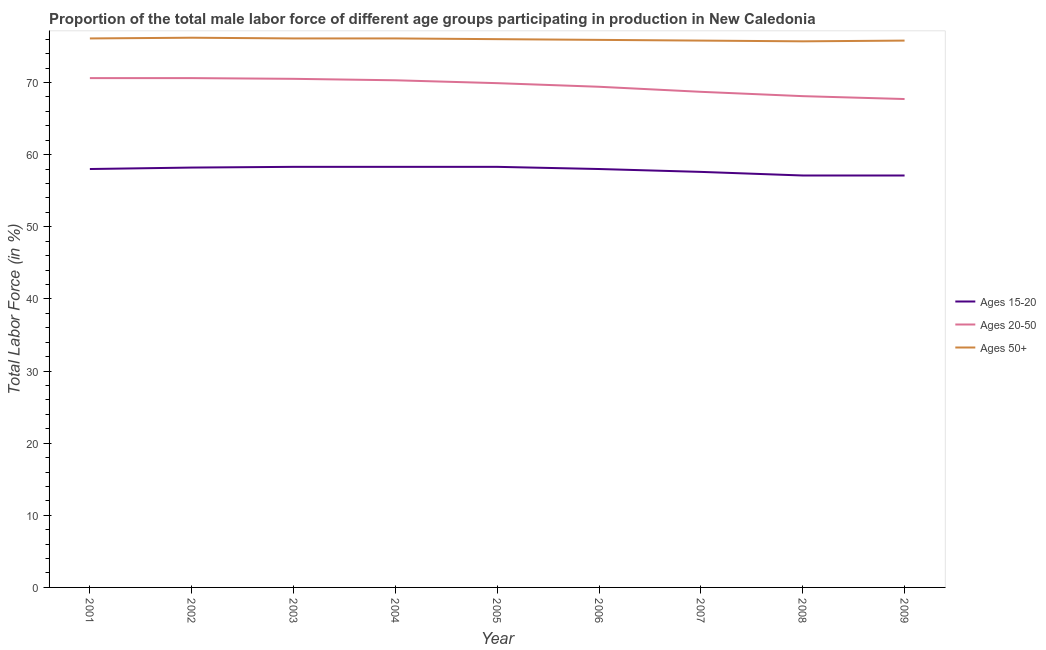What is the percentage of male labor force above age 50 in 2002?
Make the answer very short. 76.2. Across all years, what is the maximum percentage of male labor force within the age group 20-50?
Give a very brief answer. 70.6. Across all years, what is the minimum percentage of male labor force within the age group 15-20?
Provide a succinct answer. 57.1. In which year was the percentage of male labor force above age 50 minimum?
Your answer should be very brief. 2008. What is the total percentage of male labor force above age 50 in the graph?
Provide a succinct answer. 683.7. What is the difference between the percentage of male labor force within the age group 15-20 in 2005 and that in 2007?
Make the answer very short. 0.7. What is the average percentage of male labor force within the age group 15-20 per year?
Your answer should be compact. 57.88. In the year 2005, what is the difference between the percentage of male labor force above age 50 and percentage of male labor force within the age group 20-50?
Make the answer very short. 6.1. In how many years, is the percentage of male labor force within the age group 20-50 greater than 10 %?
Provide a short and direct response. 9. Is the difference between the percentage of male labor force above age 50 in 2005 and 2006 greater than the difference between the percentage of male labor force within the age group 20-50 in 2005 and 2006?
Your answer should be compact. No. In how many years, is the percentage of male labor force within the age group 15-20 greater than the average percentage of male labor force within the age group 15-20 taken over all years?
Give a very brief answer. 6. Is the sum of the percentage of male labor force above age 50 in 2002 and 2007 greater than the maximum percentage of male labor force within the age group 15-20 across all years?
Ensure brevity in your answer.  Yes. Is it the case that in every year, the sum of the percentage of male labor force within the age group 15-20 and percentage of male labor force within the age group 20-50 is greater than the percentage of male labor force above age 50?
Keep it short and to the point. Yes. What is the title of the graph?
Provide a succinct answer. Proportion of the total male labor force of different age groups participating in production in New Caledonia. Does "Errors" appear as one of the legend labels in the graph?
Give a very brief answer. No. What is the label or title of the X-axis?
Make the answer very short. Year. What is the Total Labor Force (in %) of Ages 15-20 in 2001?
Your answer should be very brief. 58. What is the Total Labor Force (in %) in Ages 20-50 in 2001?
Your answer should be very brief. 70.6. What is the Total Labor Force (in %) of Ages 50+ in 2001?
Ensure brevity in your answer.  76.1. What is the Total Labor Force (in %) of Ages 15-20 in 2002?
Make the answer very short. 58.2. What is the Total Labor Force (in %) in Ages 20-50 in 2002?
Make the answer very short. 70.6. What is the Total Labor Force (in %) of Ages 50+ in 2002?
Keep it short and to the point. 76.2. What is the Total Labor Force (in %) in Ages 15-20 in 2003?
Your answer should be compact. 58.3. What is the Total Labor Force (in %) in Ages 20-50 in 2003?
Your response must be concise. 70.5. What is the Total Labor Force (in %) in Ages 50+ in 2003?
Your answer should be very brief. 76.1. What is the Total Labor Force (in %) of Ages 15-20 in 2004?
Offer a very short reply. 58.3. What is the Total Labor Force (in %) in Ages 20-50 in 2004?
Provide a short and direct response. 70.3. What is the Total Labor Force (in %) in Ages 50+ in 2004?
Your answer should be compact. 76.1. What is the Total Labor Force (in %) of Ages 15-20 in 2005?
Give a very brief answer. 58.3. What is the Total Labor Force (in %) of Ages 20-50 in 2005?
Your response must be concise. 69.9. What is the Total Labor Force (in %) of Ages 50+ in 2005?
Your answer should be compact. 76. What is the Total Labor Force (in %) in Ages 15-20 in 2006?
Keep it short and to the point. 58. What is the Total Labor Force (in %) in Ages 20-50 in 2006?
Ensure brevity in your answer.  69.4. What is the Total Labor Force (in %) in Ages 50+ in 2006?
Ensure brevity in your answer.  75.9. What is the Total Labor Force (in %) in Ages 15-20 in 2007?
Give a very brief answer. 57.6. What is the Total Labor Force (in %) of Ages 20-50 in 2007?
Ensure brevity in your answer.  68.7. What is the Total Labor Force (in %) of Ages 50+ in 2007?
Your answer should be very brief. 75.8. What is the Total Labor Force (in %) of Ages 15-20 in 2008?
Offer a very short reply. 57.1. What is the Total Labor Force (in %) in Ages 20-50 in 2008?
Your answer should be compact. 68.1. What is the Total Labor Force (in %) of Ages 50+ in 2008?
Make the answer very short. 75.7. What is the Total Labor Force (in %) of Ages 15-20 in 2009?
Ensure brevity in your answer.  57.1. What is the Total Labor Force (in %) in Ages 20-50 in 2009?
Offer a terse response. 67.7. What is the Total Labor Force (in %) of Ages 50+ in 2009?
Your response must be concise. 75.8. Across all years, what is the maximum Total Labor Force (in %) in Ages 15-20?
Provide a succinct answer. 58.3. Across all years, what is the maximum Total Labor Force (in %) in Ages 20-50?
Make the answer very short. 70.6. Across all years, what is the maximum Total Labor Force (in %) of Ages 50+?
Make the answer very short. 76.2. Across all years, what is the minimum Total Labor Force (in %) of Ages 15-20?
Ensure brevity in your answer.  57.1. Across all years, what is the minimum Total Labor Force (in %) in Ages 20-50?
Give a very brief answer. 67.7. Across all years, what is the minimum Total Labor Force (in %) in Ages 50+?
Make the answer very short. 75.7. What is the total Total Labor Force (in %) in Ages 15-20 in the graph?
Ensure brevity in your answer.  520.9. What is the total Total Labor Force (in %) of Ages 20-50 in the graph?
Offer a very short reply. 625.8. What is the total Total Labor Force (in %) of Ages 50+ in the graph?
Your answer should be compact. 683.7. What is the difference between the Total Labor Force (in %) in Ages 15-20 in 2001 and that in 2002?
Your response must be concise. -0.2. What is the difference between the Total Labor Force (in %) in Ages 20-50 in 2001 and that in 2002?
Provide a short and direct response. 0. What is the difference between the Total Labor Force (in %) of Ages 50+ in 2001 and that in 2002?
Offer a terse response. -0.1. What is the difference between the Total Labor Force (in %) of Ages 15-20 in 2001 and that in 2003?
Your response must be concise. -0.3. What is the difference between the Total Labor Force (in %) of Ages 15-20 in 2001 and that in 2004?
Offer a terse response. -0.3. What is the difference between the Total Labor Force (in %) of Ages 50+ in 2001 and that in 2004?
Offer a terse response. 0. What is the difference between the Total Labor Force (in %) of Ages 50+ in 2001 and that in 2005?
Make the answer very short. 0.1. What is the difference between the Total Labor Force (in %) in Ages 15-20 in 2001 and that in 2006?
Provide a short and direct response. 0. What is the difference between the Total Labor Force (in %) of Ages 20-50 in 2001 and that in 2006?
Ensure brevity in your answer.  1.2. What is the difference between the Total Labor Force (in %) in Ages 50+ in 2001 and that in 2006?
Your answer should be very brief. 0.2. What is the difference between the Total Labor Force (in %) of Ages 15-20 in 2001 and that in 2007?
Your response must be concise. 0.4. What is the difference between the Total Labor Force (in %) in Ages 50+ in 2001 and that in 2007?
Offer a terse response. 0.3. What is the difference between the Total Labor Force (in %) in Ages 15-20 in 2001 and that in 2008?
Your response must be concise. 0.9. What is the difference between the Total Labor Force (in %) of Ages 20-50 in 2001 and that in 2008?
Make the answer very short. 2.5. What is the difference between the Total Labor Force (in %) of Ages 20-50 in 2001 and that in 2009?
Make the answer very short. 2.9. What is the difference between the Total Labor Force (in %) in Ages 50+ in 2001 and that in 2009?
Offer a very short reply. 0.3. What is the difference between the Total Labor Force (in %) in Ages 15-20 in 2002 and that in 2003?
Ensure brevity in your answer.  -0.1. What is the difference between the Total Labor Force (in %) in Ages 50+ in 2002 and that in 2003?
Make the answer very short. 0.1. What is the difference between the Total Labor Force (in %) in Ages 20-50 in 2002 and that in 2004?
Offer a terse response. 0.3. What is the difference between the Total Labor Force (in %) in Ages 20-50 in 2002 and that in 2006?
Your answer should be very brief. 1.2. What is the difference between the Total Labor Force (in %) of Ages 50+ in 2002 and that in 2006?
Provide a short and direct response. 0.3. What is the difference between the Total Labor Force (in %) in Ages 20-50 in 2002 and that in 2007?
Give a very brief answer. 1.9. What is the difference between the Total Labor Force (in %) of Ages 20-50 in 2002 and that in 2009?
Provide a succinct answer. 2.9. What is the difference between the Total Labor Force (in %) of Ages 15-20 in 2003 and that in 2004?
Provide a succinct answer. 0. What is the difference between the Total Labor Force (in %) of Ages 50+ in 2003 and that in 2005?
Your answer should be compact. 0.1. What is the difference between the Total Labor Force (in %) in Ages 15-20 in 2003 and that in 2006?
Offer a very short reply. 0.3. What is the difference between the Total Labor Force (in %) in Ages 20-50 in 2003 and that in 2006?
Your answer should be very brief. 1.1. What is the difference between the Total Labor Force (in %) of Ages 15-20 in 2003 and that in 2007?
Offer a very short reply. 0.7. What is the difference between the Total Labor Force (in %) of Ages 20-50 in 2003 and that in 2008?
Your answer should be compact. 2.4. What is the difference between the Total Labor Force (in %) in Ages 50+ in 2003 and that in 2008?
Make the answer very short. 0.4. What is the difference between the Total Labor Force (in %) of Ages 15-20 in 2003 and that in 2009?
Offer a very short reply. 1.2. What is the difference between the Total Labor Force (in %) in Ages 20-50 in 2003 and that in 2009?
Ensure brevity in your answer.  2.8. What is the difference between the Total Labor Force (in %) of Ages 15-20 in 2004 and that in 2005?
Provide a short and direct response. 0. What is the difference between the Total Labor Force (in %) of Ages 20-50 in 2004 and that in 2005?
Offer a terse response. 0.4. What is the difference between the Total Labor Force (in %) in Ages 15-20 in 2004 and that in 2006?
Provide a short and direct response. 0.3. What is the difference between the Total Labor Force (in %) of Ages 50+ in 2004 and that in 2006?
Offer a very short reply. 0.2. What is the difference between the Total Labor Force (in %) of Ages 15-20 in 2004 and that in 2007?
Ensure brevity in your answer.  0.7. What is the difference between the Total Labor Force (in %) in Ages 15-20 in 2004 and that in 2008?
Offer a terse response. 1.2. What is the difference between the Total Labor Force (in %) of Ages 15-20 in 2004 and that in 2009?
Offer a terse response. 1.2. What is the difference between the Total Labor Force (in %) of Ages 50+ in 2004 and that in 2009?
Provide a succinct answer. 0.3. What is the difference between the Total Labor Force (in %) in Ages 15-20 in 2005 and that in 2006?
Keep it short and to the point. 0.3. What is the difference between the Total Labor Force (in %) of Ages 50+ in 2005 and that in 2006?
Keep it short and to the point. 0.1. What is the difference between the Total Labor Force (in %) of Ages 15-20 in 2005 and that in 2008?
Offer a very short reply. 1.2. What is the difference between the Total Labor Force (in %) in Ages 20-50 in 2005 and that in 2008?
Offer a terse response. 1.8. What is the difference between the Total Labor Force (in %) of Ages 50+ in 2005 and that in 2008?
Ensure brevity in your answer.  0.3. What is the difference between the Total Labor Force (in %) of Ages 50+ in 2005 and that in 2009?
Offer a terse response. 0.2. What is the difference between the Total Labor Force (in %) of Ages 15-20 in 2006 and that in 2007?
Give a very brief answer. 0.4. What is the difference between the Total Labor Force (in %) in Ages 20-50 in 2006 and that in 2008?
Your answer should be compact. 1.3. What is the difference between the Total Labor Force (in %) in Ages 50+ in 2006 and that in 2008?
Provide a succinct answer. 0.2. What is the difference between the Total Labor Force (in %) of Ages 15-20 in 2006 and that in 2009?
Ensure brevity in your answer.  0.9. What is the difference between the Total Labor Force (in %) in Ages 20-50 in 2006 and that in 2009?
Offer a terse response. 1.7. What is the difference between the Total Labor Force (in %) in Ages 15-20 in 2007 and that in 2008?
Offer a very short reply. 0.5. What is the difference between the Total Labor Force (in %) in Ages 20-50 in 2007 and that in 2008?
Make the answer very short. 0.6. What is the difference between the Total Labor Force (in %) of Ages 50+ in 2007 and that in 2008?
Keep it short and to the point. 0.1. What is the difference between the Total Labor Force (in %) in Ages 50+ in 2007 and that in 2009?
Ensure brevity in your answer.  0. What is the difference between the Total Labor Force (in %) in Ages 50+ in 2008 and that in 2009?
Provide a succinct answer. -0.1. What is the difference between the Total Labor Force (in %) in Ages 15-20 in 2001 and the Total Labor Force (in %) in Ages 20-50 in 2002?
Offer a very short reply. -12.6. What is the difference between the Total Labor Force (in %) in Ages 15-20 in 2001 and the Total Labor Force (in %) in Ages 50+ in 2002?
Ensure brevity in your answer.  -18.2. What is the difference between the Total Labor Force (in %) in Ages 15-20 in 2001 and the Total Labor Force (in %) in Ages 50+ in 2003?
Your answer should be very brief. -18.1. What is the difference between the Total Labor Force (in %) of Ages 20-50 in 2001 and the Total Labor Force (in %) of Ages 50+ in 2003?
Give a very brief answer. -5.5. What is the difference between the Total Labor Force (in %) in Ages 15-20 in 2001 and the Total Labor Force (in %) in Ages 50+ in 2004?
Ensure brevity in your answer.  -18.1. What is the difference between the Total Labor Force (in %) of Ages 15-20 in 2001 and the Total Labor Force (in %) of Ages 20-50 in 2005?
Keep it short and to the point. -11.9. What is the difference between the Total Labor Force (in %) in Ages 20-50 in 2001 and the Total Labor Force (in %) in Ages 50+ in 2005?
Give a very brief answer. -5.4. What is the difference between the Total Labor Force (in %) in Ages 15-20 in 2001 and the Total Labor Force (in %) in Ages 20-50 in 2006?
Your answer should be very brief. -11.4. What is the difference between the Total Labor Force (in %) in Ages 15-20 in 2001 and the Total Labor Force (in %) in Ages 50+ in 2006?
Make the answer very short. -17.9. What is the difference between the Total Labor Force (in %) of Ages 20-50 in 2001 and the Total Labor Force (in %) of Ages 50+ in 2006?
Offer a very short reply. -5.3. What is the difference between the Total Labor Force (in %) in Ages 15-20 in 2001 and the Total Labor Force (in %) in Ages 50+ in 2007?
Make the answer very short. -17.8. What is the difference between the Total Labor Force (in %) in Ages 15-20 in 2001 and the Total Labor Force (in %) in Ages 50+ in 2008?
Your answer should be compact. -17.7. What is the difference between the Total Labor Force (in %) of Ages 20-50 in 2001 and the Total Labor Force (in %) of Ages 50+ in 2008?
Make the answer very short. -5.1. What is the difference between the Total Labor Force (in %) in Ages 15-20 in 2001 and the Total Labor Force (in %) in Ages 50+ in 2009?
Your answer should be very brief. -17.8. What is the difference between the Total Labor Force (in %) of Ages 15-20 in 2002 and the Total Labor Force (in %) of Ages 20-50 in 2003?
Your answer should be very brief. -12.3. What is the difference between the Total Labor Force (in %) in Ages 15-20 in 2002 and the Total Labor Force (in %) in Ages 50+ in 2003?
Provide a succinct answer. -17.9. What is the difference between the Total Labor Force (in %) of Ages 20-50 in 2002 and the Total Labor Force (in %) of Ages 50+ in 2003?
Provide a short and direct response. -5.5. What is the difference between the Total Labor Force (in %) of Ages 15-20 in 2002 and the Total Labor Force (in %) of Ages 20-50 in 2004?
Ensure brevity in your answer.  -12.1. What is the difference between the Total Labor Force (in %) in Ages 15-20 in 2002 and the Total Labor Force (in %) in Ages 50+ in 2004?
Offer a terse response. -17.9. What is the difference between the Total Labor Force (in %) of Ages 15-20 in 2002 and the Total Labor Force (in %) of Ages 50+ in 2005?
Provide a succinct answer. -17.8. What is the difference between the Total Labor Force (in %) in Ages 15-20 in 2002 and the Total Labor Force (in %) in Ages 50+ in 2006?
Offer a terse response. -17.7. What is the difference between the Total Labor Force (in %) of Ages 20-50 in 2002 and the Total Labor Force (in %) of Ages 50+ in 2006?
Ensure brevity in your answer.  -5.3. What is the difference between the Total Labor Force (in %) of Ages 15-20 in 2002 and the Total Labor Force (in %) of Ages 50+ in 2007?
Keep it short and to the point. -17.6. What is the difference between the Total Labor Force (in %) in Ages 20-50 in 2002 and the Total Labor Force (in %) in Ages 50+ in 2007?
Provide a short and direct response. -5.2. What is the difference between the Total Labor Force (in %) in Ages 15-20 in 2002 and the Total Labor Force (in %) in Ages 50+ in 2008?
Provide a succinct answer. -17.5. What is the difference between the Total Labor Force (in %) of Ages 20-50 in 2002 and the Total Labor Force (in %) of Ages 50+ in 2008?
Your response must be concise. -5.1. What is the difference between the Total Labor Force (in %) of Ages 15-20 in 2002 and the Total Labor Force (in %) of Ages 50+ in 2009?
Ensure brevity in your answer.  -17.6. What is the difference between the Total Labor Force (in %) in Ages 20-50 in 2002 and the Total Labor Force (in %) in Ages 50+ in 2009?
Keep it short and to the point. -5.2. What is the difference between the Total Labor Force (in %) of Ages 15-20 in 2003 and the Total Labor Force (in %) of Ages 50+ in 2004?
Provide a short and direct response. -17.8. What is the difference between the Total Labor Force (in %) in Ages 15-20 in 2003 and the Total Labor Force (in %) in Ages 50+ in 2005?
Give a very brief answer. -17.7. What is the difference between the Total Labor Force (in %) of Ages 20-50 in 2003 and the Total Labor Force (in %) of Ages 50+ in 2005?
Your answer should be very brief. -5.5. What is the difference between the Total Labor Force (in %) in Ages 15-20 in 2003 and the Total Labor Force (in %) in Ages 50+ in 2006?
Your answer should be very brief. -17.6. What is the difference between the Total Labor Force (in %) of Ages 15-20 in 2003 and the Total Labor Force (in %) of Ages 50+ in 2007?
Provide a succinct answer. -17.5. What is the difference between the Total Labor Force (in %) in Ages 15-20 in 2003 and the Total Labor Force (in %) in Ages 20-50 in 2008?
Offer a terse response. -9.8. What is the difference between the Total Labor Force (in %) in Ages 15-20 in 2003 and the Total Labor Force (in %) in Ages 50+ in 2008?
Keep it short and to the point. -17.4. What is the difference between the Total Labor Force (in %) of Ages 20-50 in 2003 and the Total Labor Force (in %) of Ages 50+ in 2008?
Your answer should be compact. -5.2. What is the difference between the Total Labor Force (in %) of Ages 15-20 in 2003 and the Total Labor Force (in %) of Ages 20-50 in 2009?
Keep it short and to the point. -9.4. What is the difference between the Total Labor Force (in %) of Ages 15-20 in 2003 and the Total Labor Force (in %) of Ages 50+ in 2009?
Your answer should be very brief. -17.5. What is the difference between the Total Labor Force (in %) in Ages 20-50 in 2003 and the Total Labor Force (in %) in Ages 50+ in 2009?
Your answer should be compact. -5.3. What is the difference between the Total Labor Force (in %) in Ages 15-20 in 2004 and the Total Labor Force (in %) in Ages 20-50 in 2005?
Ensure brevity in your answer.  -11.6. What is the difference between the Total Labor Force (in %) in Ages 15-20 in 2004 and the Total Labor Force (in %) in Ages 50+ in 2005?
Your response must be concise. -17.7. What is the difference between the Total Labor Force (in %) in Ages 15-20 in 2004 and the Total Labor Force (in %) in Ages 20-50 in 2006?
Give a very brief answer. -11.1. What is the difference between the Total Labor Force (in %) of Ages 15-20 in 2004 and the Total Labor Force (in %) of Ages 50+ in 2006?
Give a very brief answer. -17.6. What is the difference between the Total Labor Force (in %) in Ages 15-20 in 2004 and the Total Labor Force (in %) in Ages 50+ in 2007?
Give a very brief answer. -17.5. What is the difference between the Total Labor Force (in %) of Ages 20-50 in 2004 and the Total Labor Force (in %) of Ages 50+ in 2007?
Give a very brief answer. -5.5. What is the difference between the Total Labor Force (in %) of Ages 15-20 in 2004 and the Total Labor Force (in %) of Ages 50+ in 2008?
Offer a terse response. -17.4. What is the difference between the Total Labor Force (in %) in Ages 15-20 in 2004 and the Total Labor Force (in %) in Ages 20-50 in 2009?
Keep it short and to the point. -9.4. What is the difference between the Total Labor Force (in %) of Ages 15-20 in 2004 and the Total Labor Force (in %) of Ages 50+ in 2009?
Keep it short and to the point. -17.5. What is the difference between the Total Labor Force (in %) in Ages 15-20 in 2005 and the Total Labor Force (in %) in Ages 20-50 in 2006?
Offer a terse response. -11.1. What is the difference between the Total Labor Force (in %) in Ages 15-20 in 2005 and the Total Labor Force (in %) in Ages 50+ in 2006?
Provide a succinct answer. -17.6. What is the difference between the Total Labor Force (in %) of Ages 20-50 in 2005 and the Total Labor Force (in %) of Ages 50+ in 2006?
Give a very brief answer. -6. What is the difference between the Total Labor Force (in %) in Ages 15-20 in 2005 and the Total Labor Force (in %) in Ages 50+ in 2007?
Provide a short and direct response. -17.5. What is the difference between the Total Labor Force (in %) of Ages 15-20 in 2005 and the Total Labor Force (in %) of Ages 20-50 in 2008?
Offer a terse response. -9.8. What is the difference between the Total Labor Force (in %) in Ages 15-20 in 2005 and the Total Labor Force (in %) in Ages 50+ in 2008?
Your response must be concise. -17.4. What is the difference between the Total Labor Force (in %) of Ages 15-20 in 2005 and the Total Labor Force (in %) of Ages 20-50 in 2009?
Your answer should be very brief. -9.4. What is the difference between the Total Labor Force (in %) of Ages 15-20 in 2005 and the Total Labor Force (in %) of Ages 50+ in 2009?
Give a very brief answer. -17.5. What is the difference between the Total Labor Force (in %) in Ages 15-20 in 2006 and the Total Labor Force (in %) in Ages 20-50 in 2007?
Your response must be concise. -10.7. What is the difference between the Total Labor Force (in %) in Ages 15-20 in 2006 and the Total Labor Force (in %) in Ages 50+ in 2007?
Provide a short and direct response. -17.8. What is the difference between the Total Labor Force (in %) of Ages 20-50 in 2006 and the Total Labor Force (in %) of Ages 50+ in 2007?
Your answer should be very brief. -6.4. What is the difference between the Total Labor Force (in %) of Ages 15-20 in 2006 and the Total Labor Force (in %) of Ages 50+ in 2008?
Make the answer very short. -17.7. What is the difference between the Total Labor Force (in %) in Ages 15-20 in 2006 and the Total Labor Force (in %) in Ages 20-50 in 2009?
Provide a succinct answer. -9.7. What is the difference between the Total Labor Force (in %) of Ages 15-20 in 2006 and the Total Labor Force (in %) of Ages 50+ in 2009?
Give a very brief answer. -17.8. What is the difference between the Total Labor Force (in %) of Ages 20-50 in 2006 and the Total Labor Force (in %) of Ages 50+ in 2009?
Make the answer very short. -6.4. What is the difference between the Total Labor Force (in %) in Ages 15-20 in 2007 and the Total Labor Force (in %) in Ages 20-50 in 2008?
Keep it short and to the point. -10.5. What is the difference between the Total Labor Force (in %) of Ages 15-20 in 2007 and the Total Labor Force (in %) of Ages 50+ in 2008?
Your answer should be very brief. -18.1. What is the difference between the Total Labor Force (in %) in Ages 20-50 in 2007 and the Total Labor Force (in %) in Ages 50+ in 2008?
Your answer should be very brief. -7. What is the difference between the Total Labor Force (in %) of Ages 15-20 in 2007 and the Total Labor Force (in %) of Ages 20-50 in 2009?
Your response must be concise. -10.1. What is the difference between the Total Labor Force (in %) in Ages 15-20 in 2007 and the Total Labor Force (in %) in Ages 50+ in 2009?
Make the answer very short. -18.2. What is the difference between the Total Labor Force (in %) of Ages 15-20 in 2008 and the Total Labor Force (in %) of Ages 20-50 in 2009?
Give a very brief answer. -10.6. What is the difference between the Total Labor Force (in %) of Ages 15-20 in 2008 and the Total Labor Force (in %) of Ages 50+ in 2009?
Make the answer very short. -18.7. What is the average Total Labor Force (in %) in Ages 15-20 per year?
Your response must be concise. 57.88. What is the average Total Labor Force (in %) of Ages 20-50 per year?
Make the answer very short. 69.53. What is the average Total Labor Force (in %) in Ages 50+ per year?
Offer a terse response. 75.97. In the year 2001, what is the difference between the Total Labor Force (in %) of Ages 15-20 and Total Labor Force (in %) of Ages 20-50?
Your answer should be compact. -12.6. In the year 2001, what is the difference between the Total Labor Force (in %) of Ages 15-20 and Total Labor Force (in %) of Ages 50+?
Your response must be concise. -18.1. In the year 2002, what is the difference between the Total Labor Force (in %) in Ages 15-20 and Total Labor Force (in %) in Ages 50+?
Provide a short and direct response. -18. In the year 2002, what is the difference between the Total Labor Force (in %) of Ages 20-50 and Total Labor Force (in %) of Ages 50+?
Your answer should be very brief. -5.6. In the year 2003, what is the difference between the Total Labor Force (in %) in Ages 15-20 and Total Labor Force (in %) in Ages 20-50?
Your answer should be very brief. -12.2. In the year 2003, what is the difference between the Total Labor Force (in %) of Ages 15-20 and Total Labor Force (in %) of Ages 50+?
Give a very brief answer. -17.8. In the year 2003, what is the difference between the Total Labor Force (in %) in Ages 20-50 and Total Labor Force (in %) in Ages 50+?
Keep it short and to the point. -5.6. In the year 2004, what is the difference between the Total Labor Force (in %) in Ages 15-20 and Total Labor Force (in %) in Ages 50+?
Your answer should be very brief. -17.8. In the year 2005, what is the difference between the Total Labor Force (in %) of Ages 15-20 and Total Labor Force (in %) of Ages 50+?
Your answer should be compact. -17.7. In the year 2005, what is the difference between the Total Labor Force (in %) in Ages 20-50 and Total Labor Force (in %) in Ages 50+?
Provide a short and direct response. -6.1. In the year 2006, what is the difference between the Total Labor Force (in %) in Ages 15-20 and Total Labor Force (in %) in Ages 20-50?
Offer a very short reply. -11.4. In the year 2006, what is the difference between the Total Labor Force (in %) of Ages 15-20 and Total Labor Force (in %) of Ages 50+?
Make the answer very short. -17.9. In the year 2007, what is the difference between the Total Labor Force (in %) in Ages 15-20 and Total Labor Force (in %) in Ages 20-50?
Your response must be concise. -11.1. In the year 2007, what is the difference between the Total Labor Force (in %) of Ages 15-20 and Total Labor Force (in %) of Ages 50+?
Make the answer very short. -18.2. In the year 2007, what is the difference between the Total Labor Force (in %) of Ages 20-50 and Total Labor Force (in %) of Ages 50+?
Give a very brief answer. -7.1. In the year 2008, what is the difference between the Total Labor Force (in %) in Ages 15-20 and Total Labor Force (in %) in Ages 20-50?
Keep it short and to the point. -11. In the year 2008, what is the difference between the Total Labor Force (in %) in Ages 15-20 and Total Labor Force (in %) in Ages 50+?
Your response must be concise. -18.6. In the year 2008, what is the difference between the Total Labor Force (in %) of Ages 20-50 and Total Labor Force (in %) of Ages 50+?
Your answer should be very brief. -7.6. In the year 2009, what is the difference between the Total Labor Force (in %) of Ages 15-20 and Total Labor Force (in %) of Ages 20-50?
Offer a very short reply. -10.6. In the year 2009, what is the difference between the Total Labor Force (in %) in Ages 15-20 and Total Labor Force (in %) in Ages 50+?
Make the answer very short. -18.7. What is the ratio of the Total Labor Force (in %) of Ages 15-20 in 2001 to that in 2002?
Provide a short and direct response. 1. What is the ratio of the Total Labor Force (in %) of Ages 20-50 in 2001 to that in 2003?
Provide a succinct answer. 1. What is the ratio of the Total Labor Force (in %) of Ages 15-20 in 2001 to that in 2004?
Provide a short and direct response. 0.99. What is the ratio of the Total Labor Force (in %) in Ages 20-50 in 2001 to that in 2004?
Ensure brevity in your answer.  1. What is the ratio of the Total Labor Force (in %) in Ages 50+ in 2001 to that in 2004?
Your answer should be compact. 1. What is the ratio of the Total Labor Force (in %) of Ages 15-20 in 2001 to that in 2005?
Your answer should be compact. 0.99. What is the ratio of the Total Labor Force (in %) of Ages 20-50 in 2001 to that in 2005?
Your answer should be very brief. 1.01. What is the ratio of the Total Labor Force (in %) in Ages 50+ in 2001 to that in 2005?
Provide a short and direct response. 1. What is the ratio of the Total Labor Force (in %) of Ages 20-50 in 2001 to that in 2006?
Provide a short and direct response. 1.02. What is the ratio of the Total Labor Force (in %) of Ages 15-20 in 2001 to that in 2007?
Provide a short and direct response. 1.01. What is the ratio of the Total Labor Force (in %) in Ages 20-50 in 2001 to that in 2007?
Provide a succinct answer. 1.03. What is the ratio of the Total Labor Force (in %) in Ages 50+ in 2001 to that in 2007?
Give a very brief answer. 1. What is the ratio of the Total Labor Force (in %) in Ages 15-20 in 2001 to that in 2008?
Provide a succinct answer. 1.02. What is the ratio of the Total Labor Force (in %) of Ages 20-50 in 2001 to that in 2008?
Provide a short and direct response. 1.04. What is the ratio of the Total Labor Force (in %) of Ages 15-20 in 2001 to that in 2009?
Offer a terse response. 1.02. What is the ratio of the Total Labor Force (in %) of Ages 20-50 in 2001 to that in 2009?
Your answer should be compact. 1.04. What is the ratio of the Total Labor Force (in %) in Ages 15-20 in 2002 to that in 2003?
Make the answer very short. 1. What is the ratio of the Total Labor Force (in %) in Ages 50+ in 2002 to that in 2003?
Ensure brevity in your answer.  1. What is the ratio of the Total Labor Force (in %) in Ages 15-20 in 2002 to that in 2004?
Give a very brief answer. 1. What is the ratio of the Total Labor Force (in %) in Ages 20-50 in 2002 to that in 2004?
Ensure brevity in your answer.  1. What is the ratio of the Total Labor Force (in %) in Ages 50+ in 2002 to that in 2004?
Keep it short and to the point. 1. What is the ratio of the Total Labor Force (in %) of Ages 50+ in 2002 to that in 2005?
Give a very brief answer. 1. What is the ratio of the Total Labor Force (in %) in Ages 15-20 in 2002 to that in 2006?
Your answer should be very brief. 1. What is the ratio of the Total Labor Force (in %) of Ages 20-50 in 2002 to that in 2006?
Give a very brief answer. 1.02. What is the ratio of the Total Labor Force (in %) of Ages 50+ in 2002 to that in 2006?
Provide a succinct answer. 1. What is the ratio of the Total Labor Force (in %) in Ages 15-20 in 2002 to that in 2007?
Make the answer very short. 1.01. What is the ratio of the Total Labor Force (in %) in Ages 20-50 in 2002 to that in 2007?
Offer a terse response. 1.03. What is the ratio of the Total Labor Force (in %) of Ages 50+ in 2002 to that in 2007?
Provide a succinct answer. 1.01. What is the ratio of the Total Labor Force (in %) in Ages 15-20 in 2002 to that in 2008?
Keep it short and to the point. 1.02. What is the ratio of the Total Labor Force (in %) in Ages 20-50 in 2002 to that in 2008?
Give a very brief answer. 1.04. What is the ratio of the Total Labor Force (in %) in Ages 50+ in 2002 to that in 2008?
Provide a short and direct response. 1.01. What is the ratio of the Total Labor Force (in %) of Ages 15-20 in 2002 to that in 2009?
Ensure brevity in your answer.  1.02. What is the ratio of the Total Labor Force (in %) in Ages 20-50 in 2002 to that in 2009?
Keep it short and to the point. 1.04. What is the ratio of the Total Labor Force (in %) in Ages 50+ in 2002 to that in 2009?
Your answer should be very brief. 1.01. What is the ratio of the Total Labor Force (in %) of Ages 15-20 in 2003 to that in 2005?
Give a very brief answer. 1. What is the ratio of the Total Labor Force (in %) in Ages 20-50 in 2003 to that in 2005?
Your answer should be very brief. 1.01. What is the ratio of the Total Labor Force (in %) of Ages 15-20 in 2003 to that in 2006?
Ensure brevity in your answer.  1.01. What is the ratio of the Total Labor Force (in %) in Ages 20-50 in 2003 to that in 2006?
Give a very brief answer. 1.02. What is the ratio of the Total Labor Force (in %) in Ages 50+ in 2003 to that in 2006?
Keep it short and to the point. 1. What is the ratio of the Total Labor Force (in %) in Ages 15-20 in 2003 to that in 2007?
Give a very brief answer. 1.01. What is the ratio of the Total Labor Force (in %) in Ages 20-50 in 2003 to that in 2007?
Make the answer very short. 1.03. What is the ratio of the Total Labor Force (in %) of Ages 15-20 in 2003 to that in 2008?
Your answer should be compact. 1.02. What is the ratio of the Total Labor Force (in %) in Ages 20-50 in 2003 to that in 2008?
Make the answer very short. 1.04. What is the ratio of the Total Labor Force (in %) in Ages 50+ in 2003 to that in 2008?
Your response must be concise. 1.01. What is the ratio of the Total Labor Force (in %) of Ages 15-20 in 2003 to that in 2009?
Make the answer very short. 1.02. What is the ratio of the Total Labor Force (in %) of Ages 20-50 in 2003 to that in 2009?
Provide a succinct answer. 1.04. What is the ratio of the Total Labor Force (in %) of Ages 15-20 in 2004 to that in 2005?
Provide a short and direct response. 1. What is the ratio of the Total Labor Force (in %) of Ages 50+ in 2004 to that in 2005?
Offer a very short reply. 1. What is the ratio of the Total Labor Force (in %) in Ages 20-50 in 2004 to that in 2006?
Ensure brevity in your answer.  1.01. What is the ratio of the Total Labor Force (in %) in Ages 50+ in 2004 to that in 2006?
Your response must be concise. 1. What is the ratio of the Total Labor Force (in %) of Ages 15-20 in 2004 to that in 2007?
Your answer should be very brief. 1.01. What is the ratio of the Total Labor Force (in %) of Ages 20-50 in 2004 to that in 2007?
Make the answer very short. 1.02. What is the ratio of the Total Labor Force (in %) of Ages 50+ in 2004 to that in 2007?
Provide a succinct answer. 1. What is the ratio of the Total Labor Force (in %) of Ages 20-50 in 2004 to that in 2008?
Offer a very short reply. 1.03. What is the ratio of the Total Labor Force (in %) in Ages 15-20 in 2004 to that in 2009?
Provide a succinct answer. 1.02. What is the ratio of the Total Labor Force (in %) of Ages 20-50 in 2004 to that in 2009?
Offer a very short reply. 1.04. What is the ratio of the Total Labor Force (in %) of Ages 15-20 in 2005 to that in 2006?
Offer a very short reply. 1.01. What is the ratio of the Total Labor Force (in %) in Ages 15-20 in 2005 to that in 2007?
Keep it short and to the point. 1.01. What is the ratio of the Total Labor Force (in %) in Ages 20-50 in 2005 to that in 2007?
Give a very brief answer. 1.02. What is the ratio of the Total Labor Force (in %) in Ages 50+ in 2005 to that in 2007?
Offer a terse response. 1. What is the ratio of the Total Labor Force (in %) in Ages 15-20 in 2005 to that in 2008?
Offer a very short reply. 1.02. What is the ratio of the Total Labor Force (in %) of Ages 20-50 in 2005 to that in 2008?
Offer a very short reply. 1.03. What is the ratio of the Total Labor Force (in %) of Ages 50+ in 2005 to that in 2008?
Provide a short and direct response. 1. What is the ratio of the Total Labor Force (in %) of Ages 20-50 in 2005 to that in 2009?
Ensure brevity in your answer.  1.03. What is the ratio of the Total Labor Force (in %) of Ages 15-20 in 2006 to that in 2007?
Offer a very short reply. 1.01. What is the ratio of the Total Labor Force (in %) of Ages 20-50 in 2006 to that in 2007?
Give a very brief answer. 1.01. What is the ratio of the Total Labor Force (in %) in Ages 50+ in 2006 to that in 2007?
Your answer should be very brief. 1. What is the ratio of the Total Labor Force (in %) in Ages 15-20 in 2006 to that in 2008?
Your answer should be compact. 1.02. What is the ratio of the Total Labor Force (in %) of Ages 20-50 in 2006 to that in 2008?
Give a very brief answer. 1.02. What is the ratio of the Total Labor Force (in %) in Ages 50+ in 2006 to that in 2008?
Keep it short and to the point. 1. What is the ratio of the Total Labor Force (in %) of Ages 15-20 in 2006 to that in 2009?
Offer a terse response. 1.02. What is the ratio of the Total Labor Force (in %) in Ages 20-50 in 2006 to that in 2009?
Make the answer very short. 1.03. What is the ratio of the Total Labor Force (in %) of Ages 15-20 in 2007 to that in 2008?
Your answer should be compact. 1.01. What is the ratio of the Total Labor Force (in %) of Ages 20-50 in 2007 to that in 2008?
Offer a terse response. 1.01. What is the ratio of the Total Labor Force (in %) of Ages 15-20 in 2007 to that in 2009?
Keep it short and to the point. 1.01. What is the ratio of the Total Labor Force (in %) in Ages 20-50 in 2007 to that in 2009?
Provide a succinct answer. 1.01. What is the ratio of the Total Labor Force (in %) of Ages 20-50 in 2008 to that in 2009?
Give a very brief answer. 1.01. What is the ratio of the Total Labor Force (in %) in Ages 50+ in 2008 to that in 2009?
Your response must be concise. 1. What is the difference between the highest and the second highest Total Labor Force (in %) of Ages 15-20?
Your answer should be compact. 0. What is the difference between the highest and the second highest Total Labor Force (in %) of Ages 20-50?
Make the answer very short. 0. What is the difference between the highest and the second highest Total Labor Force (in %) in Ages 50+?
Make the answer very short. 0.1. What is the difference between the highest and the lowest Total Labor Force (in %) in Ages 50+?
Your response must be concise. 0.5. 